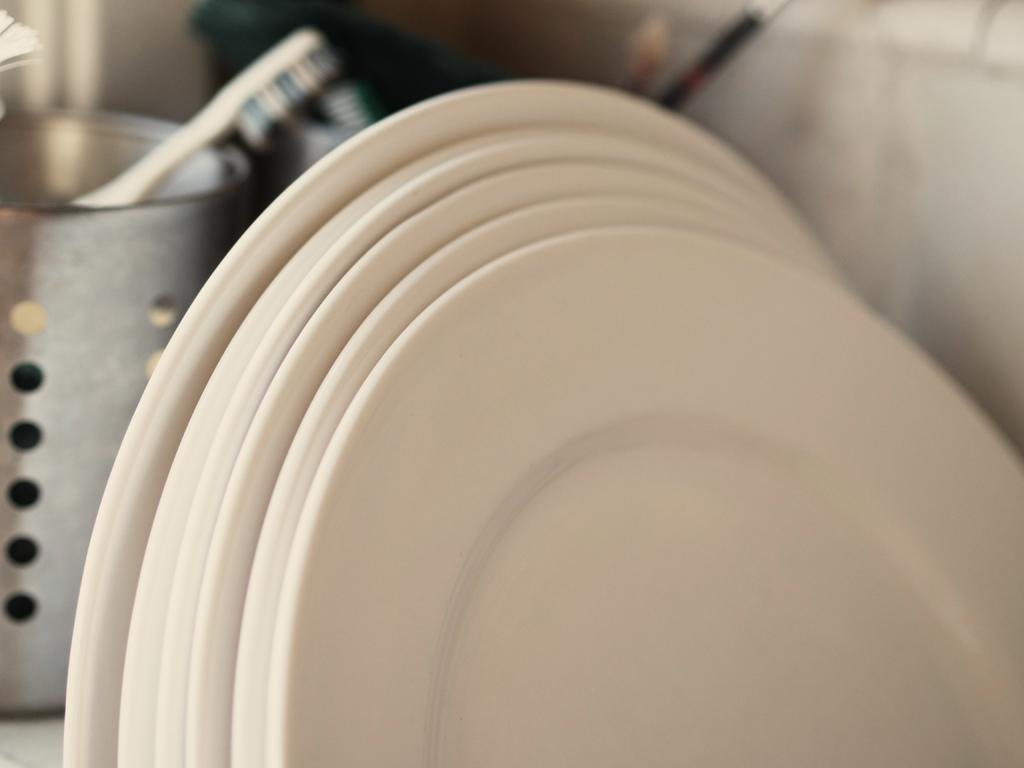What objects are in the foreground of the image? There are plates in the foreground of the image. What can be seen in the background of the image? There is a box in the background of the image. What is inside the box? There is a brush inside the box, along with additional objects. What type of cub can be seen playing with the dad in the image? There is no cub or dad present in the image; the image only features plates, a box, a brush, and additional objects inside the box. 